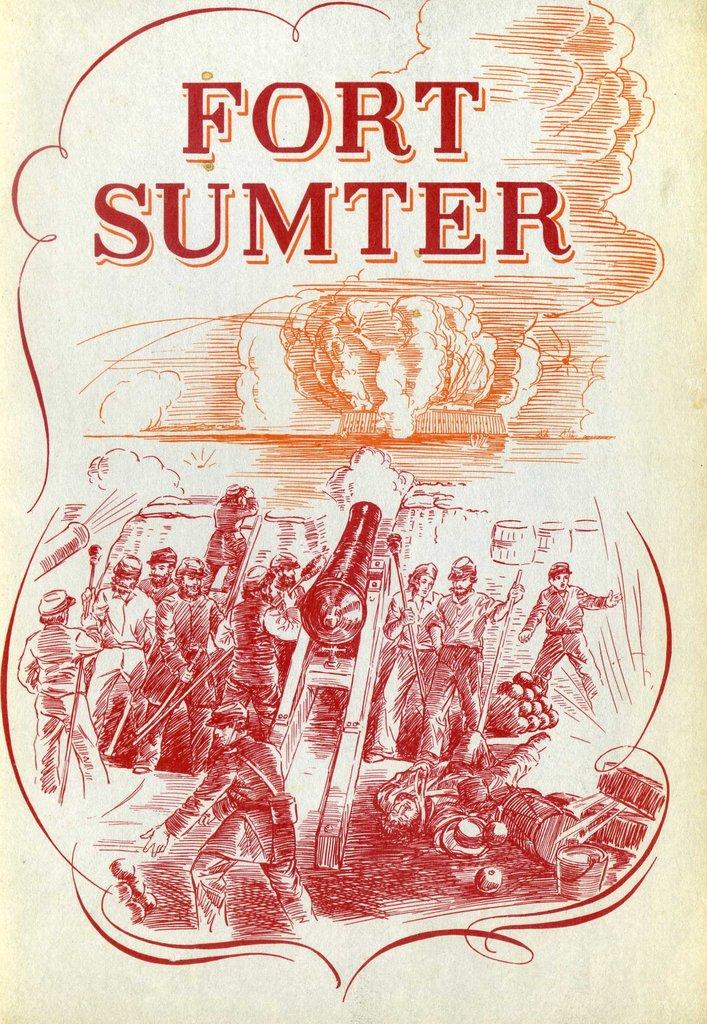What fort is referenced?
Make the answer very short. Sumter. Sumter is a what?
Offer a terse response. Fort. 